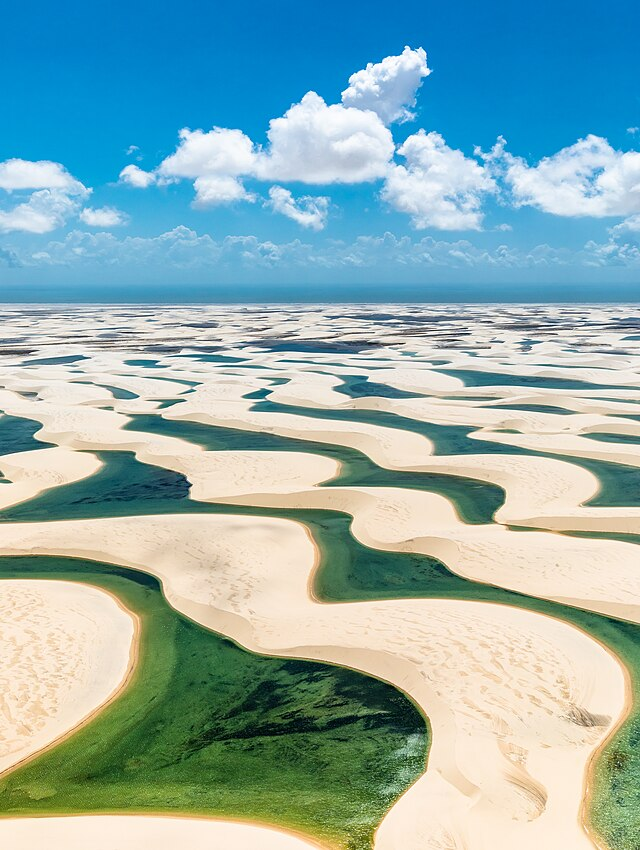Are these sand dunes stable or do they move over time? The sand dunes of the Lençóis Maranhenses are dynamic and change over time. Influenced by the wind and the seasonal ebb and flow of rainwater, the dunes gently shift, altering the park's landscape. The constant movement makes the park an ever-changing canvas—although individual alterations may not be immediately noticeable, over longer periods the topography evolves, giving each visit to the park a potential for new discovery. Does this movement affect the local wildlife in any way? Indeed, the shifting dunes create a challenging environment for local wildlife, which must adapt to the changing availability of resources like water and shelter. However, the movement of the dunes also contributes to the unique biodiversity of the park. During the rainy season, the newly formed lagoons provide habitats for a variety of aquatic species, including several fish that are uniquely adapted to this cycle of drought and abundance. 